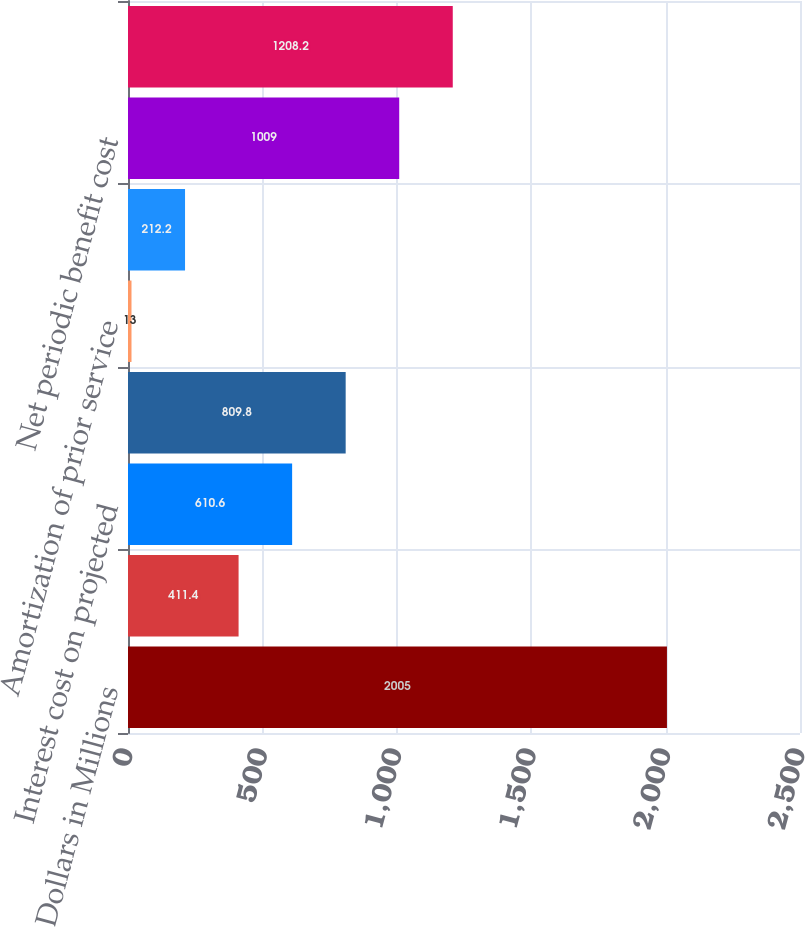<chart> <loc_0><loc_0><loc_500><loc_500><bar_chart><fcel>Dollars in Millions<fcel>Service cost - benefits earned<fcel>Interest cost on projected<fcel>Expected return on plan assets<fcel>Amortization of prior service<fcel>Amortization of loss<fcel>Net periodic benefit cost<fcel>Total net periodic benefit<nl><fcel>2005<fcel>411.4<fcel>610.6<fcel>809.8<fcel>13<fcel>212.2<fcel>1009<fcel>1208.2<nl></chart> 